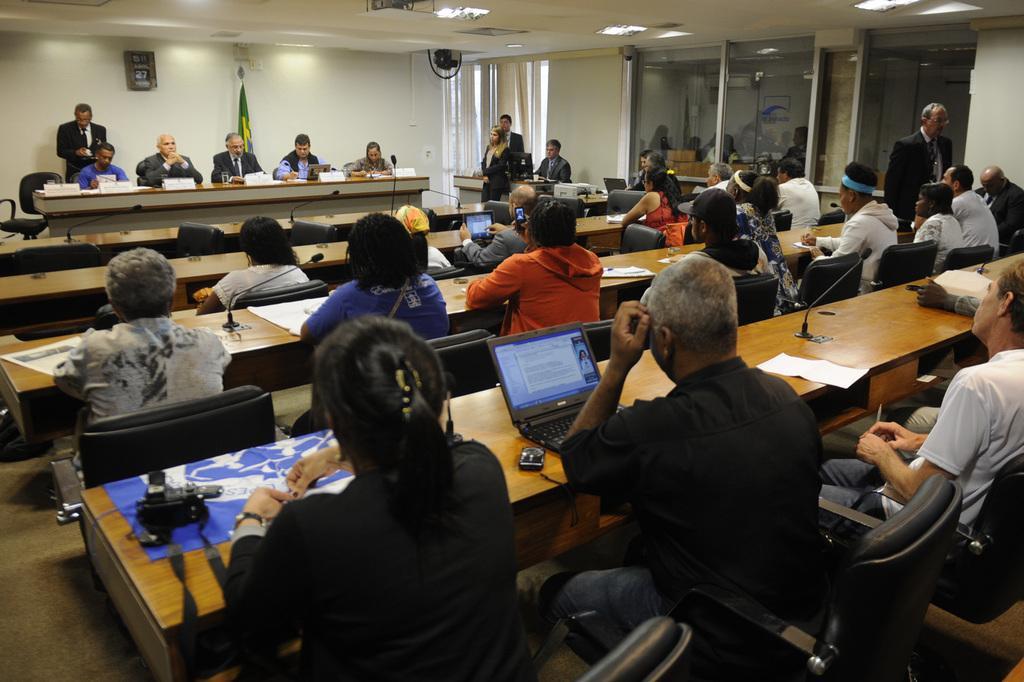In one or two sentences, can you explain what this image depicts? In this image, we can see some people wearing clothes and sitting on chairs in front of tables. There is a person at the bottom of the image sitting in front of the laptop. There are two persons sitting in front of mics. There is a flag in front of the wall. There are some persons standing and wearing clothes. There are some lights on the ceiling which is at the top of the image. 